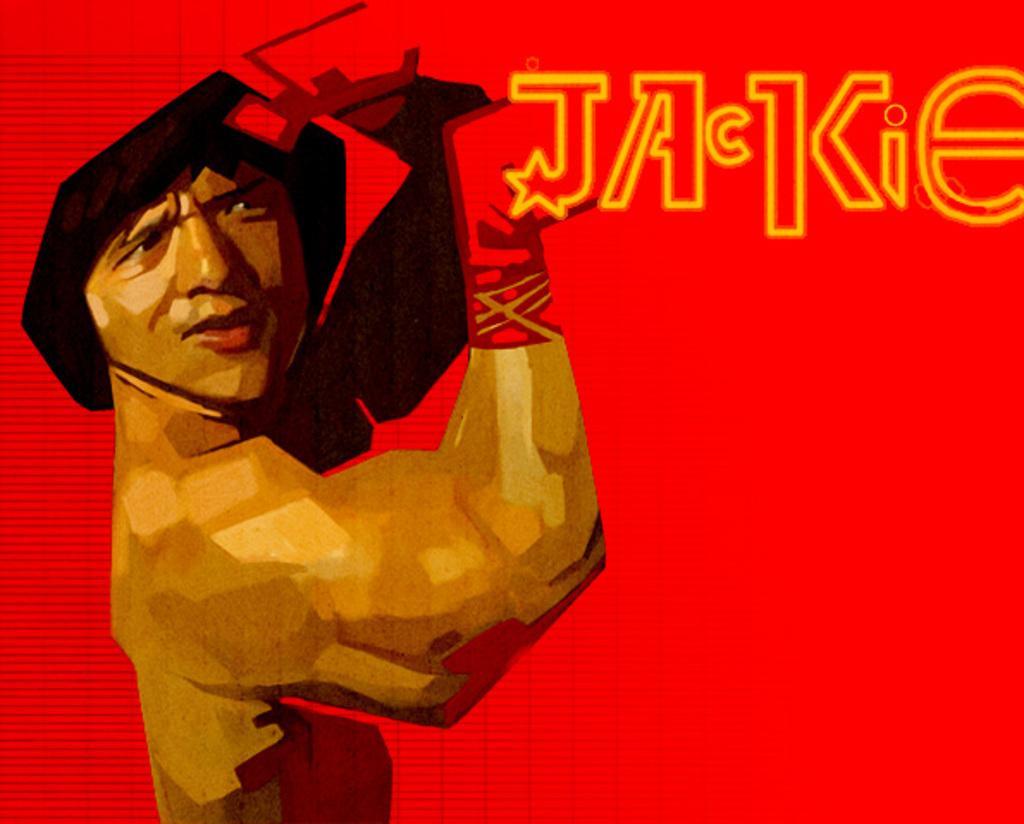How would you summarize this image in a sentence or two? In the picture I can see a man on the left side. I can see the text at the top of the image. 